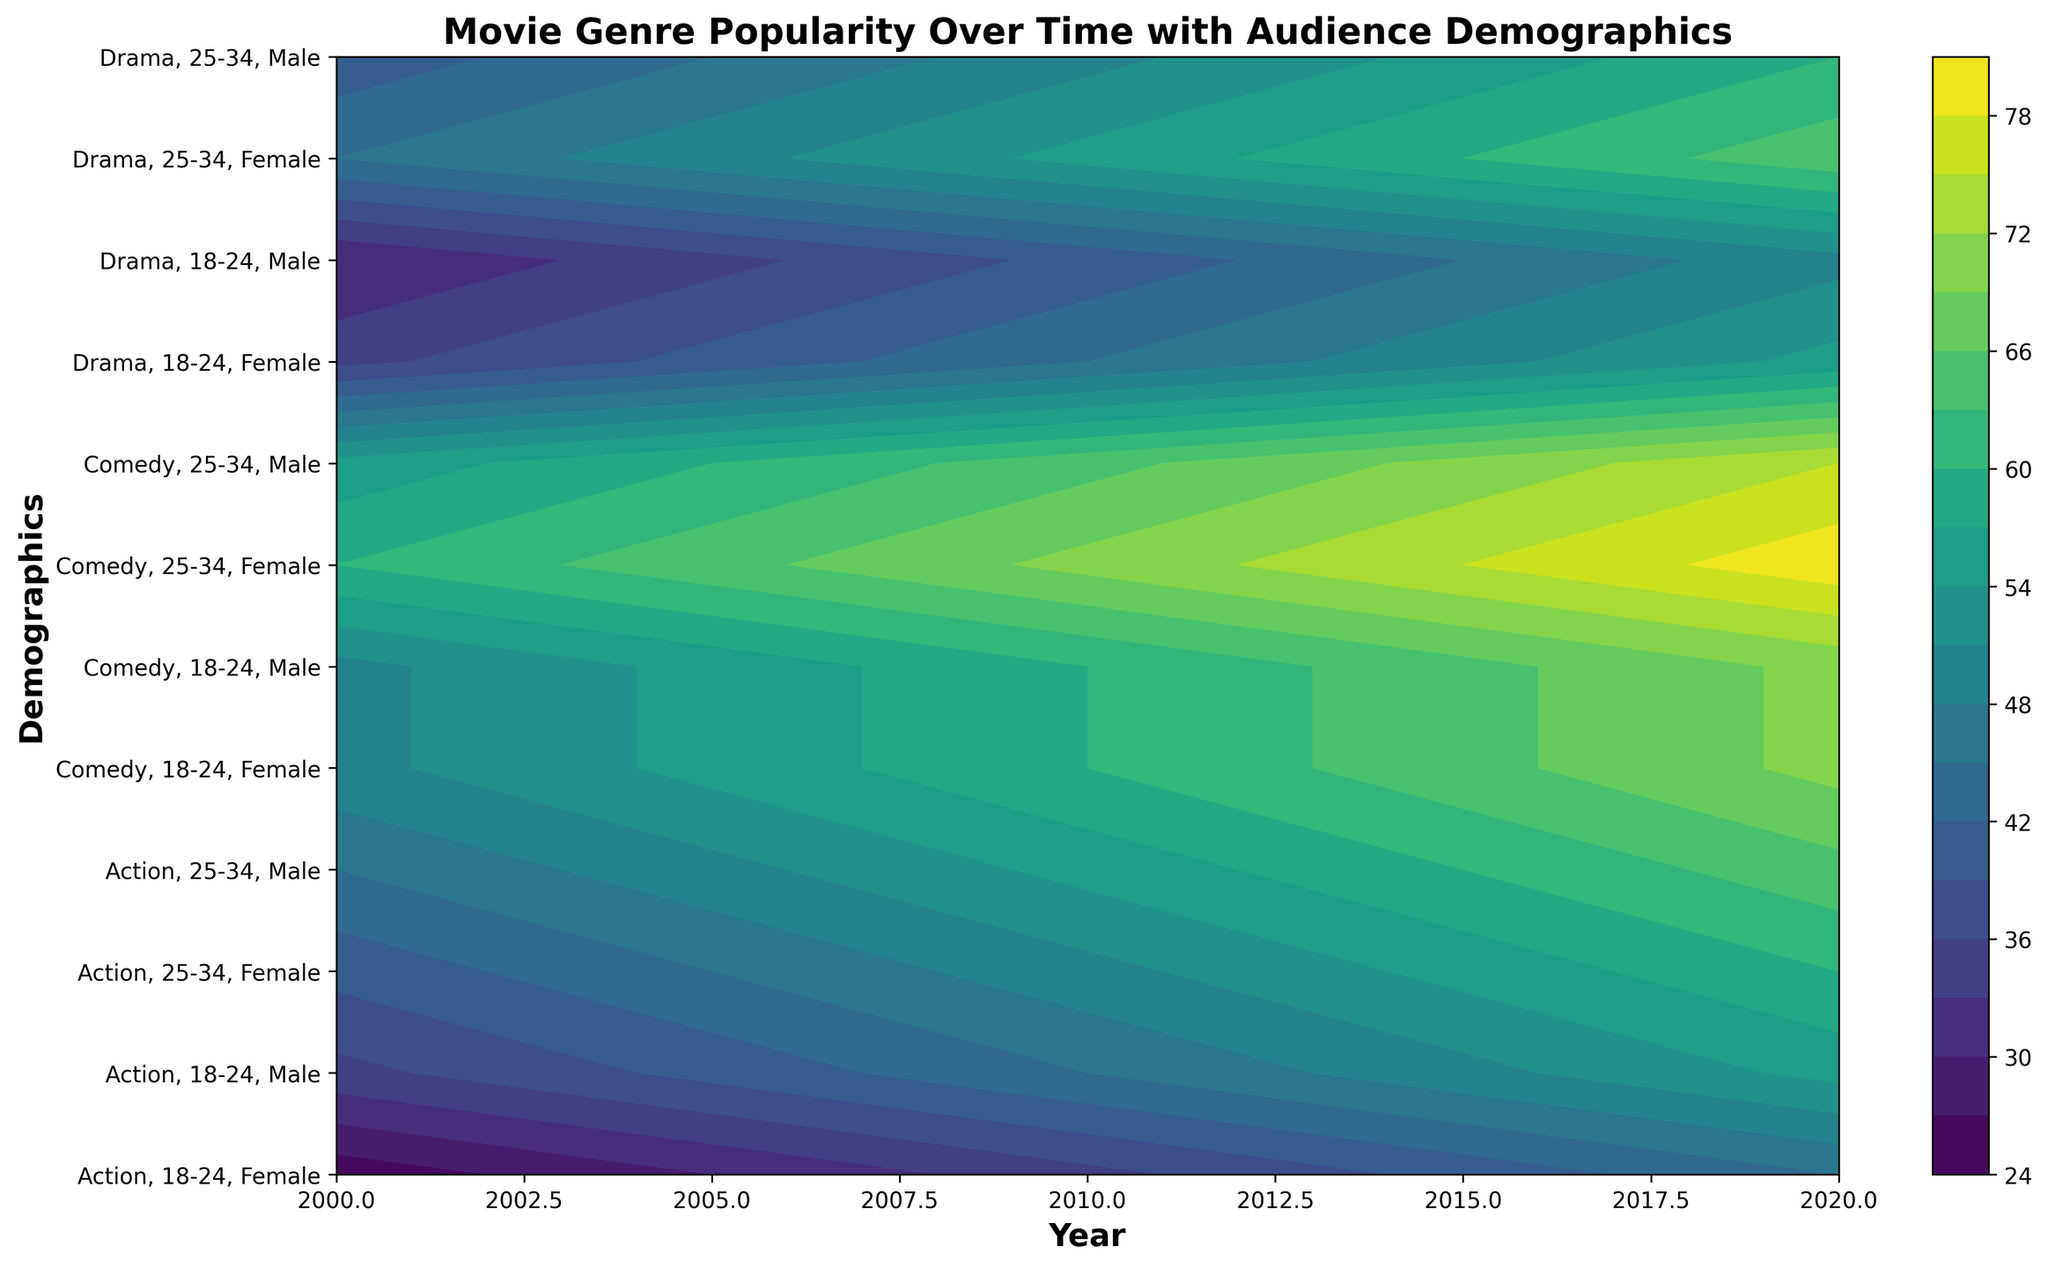Which genre had the highest popularity in 2020 for the 25-34 age group? Looking at the y-axis labels, find the demographic "Comedy, 25-34, Male" and "Comedy, 25-34, Female". These appear to have high contour levels in 2020. Comparing these levels to "Action" and "Drama" within the same demographic and year, "Comedy" has the highest popularity.
Answer: Comedy From 2000 to 2020, how did the popularity of Action movies change for males aged 18-24? Locate the contour levels for "Action, 18-24, Male" across the x-axis from 2000 to 2020. In 2000, it's moderately high, increases steadily over the years, reaching around the 60s in 2020. The popularity increased substantially.
Answer: Increased Which demographic had the most significant increase in popularity for Drama movies from 2000 to 2020? Compare the contour levels of different Drama demographics between 2000 and 2020. "Drama, 25-34, Female" shows a significant rise from a moderate level in 2000 to a high level in 2020. This rise is more pronounced than others within Drama.
Answer: 25-34, Female Between Action and Comedy, which genre was more popular among females aged 18-24 in 2015? Locate "Action, 18-24, Female" and "Comedy, 18-24, Female" on the y-axis for the year 2015. Comparing their contour levels, "Comedy" shows a higher level than "Action" for that demographic and year.
Answer: Comedy What trend can you observe in the popularity of Comedy movies for both genders in the 25-34 age group from 2000 to 2020? Looking at "Comedy, 25-34, Male" and "Comedy, 25-34, Female" along the y-axis from 2000 to 2020, the contour levels show a steady increase for both demographics, starting moderate but reaching high levels by 2020. The trend is a consistent increase in popularity.
Answer: Increasing By how many units did the popularity of Action movies for females aged 25-34 increase from 2000 to 2020? Find the contour levels for "Action, 25-34, Female" in 2000 and 2020. It appears around 40 in 2000 and around 60 in 2020. The increase is approximately 60 - 40 = 20 units.
Answer: 20 Which gender showed more interest in Drama movies for the 18-24 age group in 2000? Check the contour levels for "Drama, 18-24, Male" and "Drama, 18-24, Female" in the year 2000. "Drama, 18-24, Female" has a slightly higher contour level than males for that year and genre.
Answer: Female What is the overall trend in the popularity of Comedy movies among 18-24 males from 2000 to 2020? Follow "Comedy, 18-24, Male" across the x-axis from 2000 to 2020. The contour levels start high in 2000 and increase progressively, reaching the 70s by 2020. The trend indicates an upward movement in popularity.
Answer: Increasing Comparing the popularity of Action and Drama movies for males aged 25-34 in 2010, which genre was more popular? Observe the contour levels for "Action, 25-34, Male" and "Drama, 25-34, Male" in 2010. "Action" shows a higher contour level than "Drama" for that demographic and year.
Answer: Action 